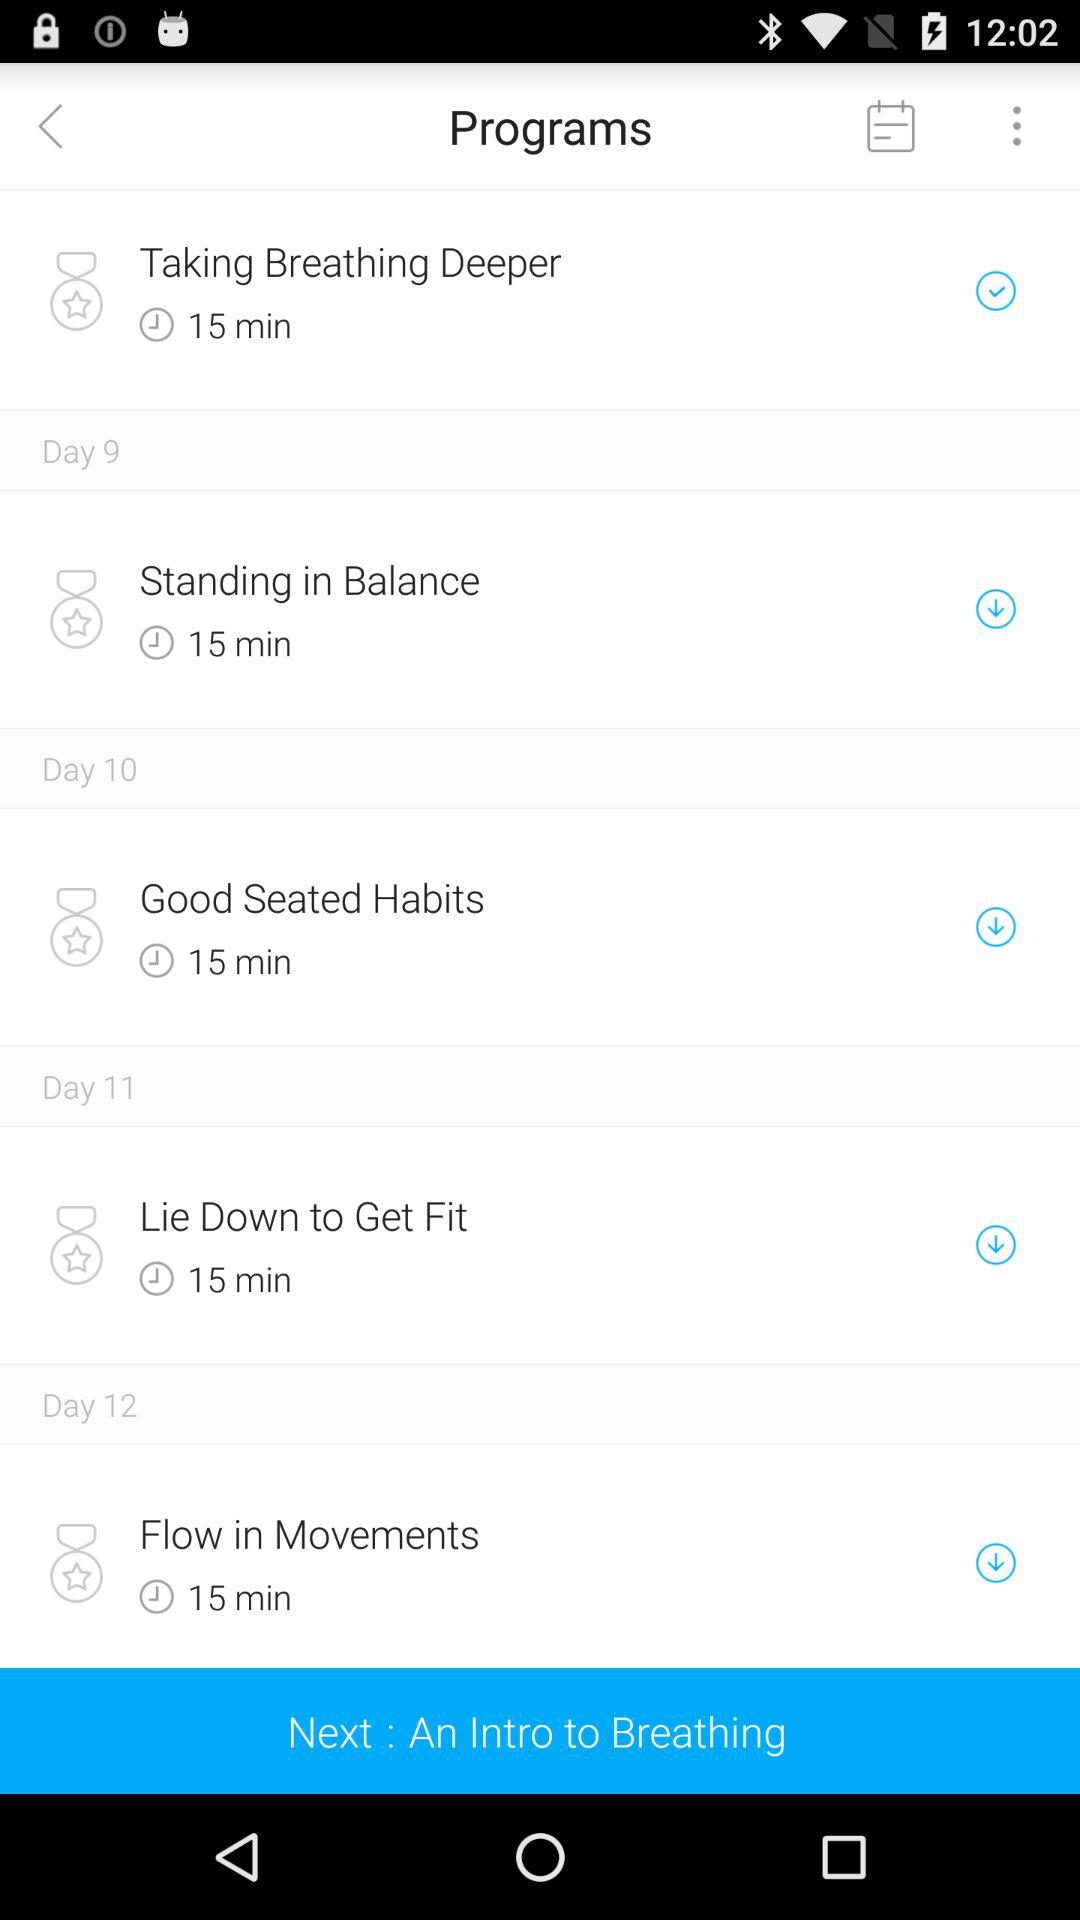How many days are there in this program?
Answer the question using a single word or phrase. 12 